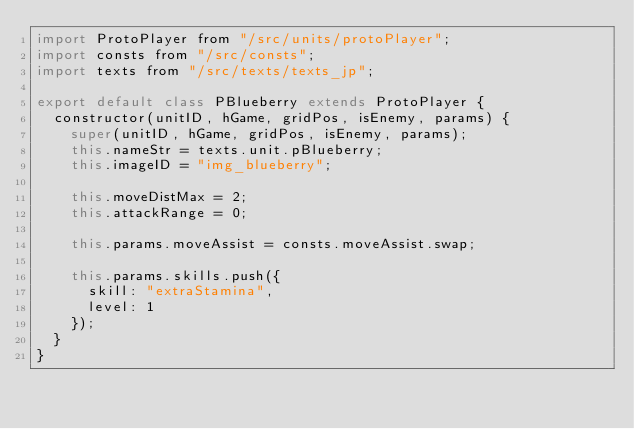Convert code to text. <code><loc_0><loc_0><loc_500><loc_500><_JavaScript_>import ProtoPlayer from "/src/units/protoPlayer";
import consts from "/src/consts";
import texts from "/src/texts/texts_jp";

export default class PBlueberry extends ProtoPlayer {
	constructor(unitID, hGame, gridPos, isEnemy, params) {
		super(unitID, hGame, gridPos, isEnemy, params);
		this.nameStr = texts.unit.pBlueberry;
		this.imageID = "img_blueberry";
		
		this.moveDistMax = 2;
		this.attackRange = 0;
		
		this.params.moveAssist = consts.moveAssist.swap;
		
		this.params.skills.push({
			skill: "extraStamina",
			level: 1
		});
	}
}</code> 